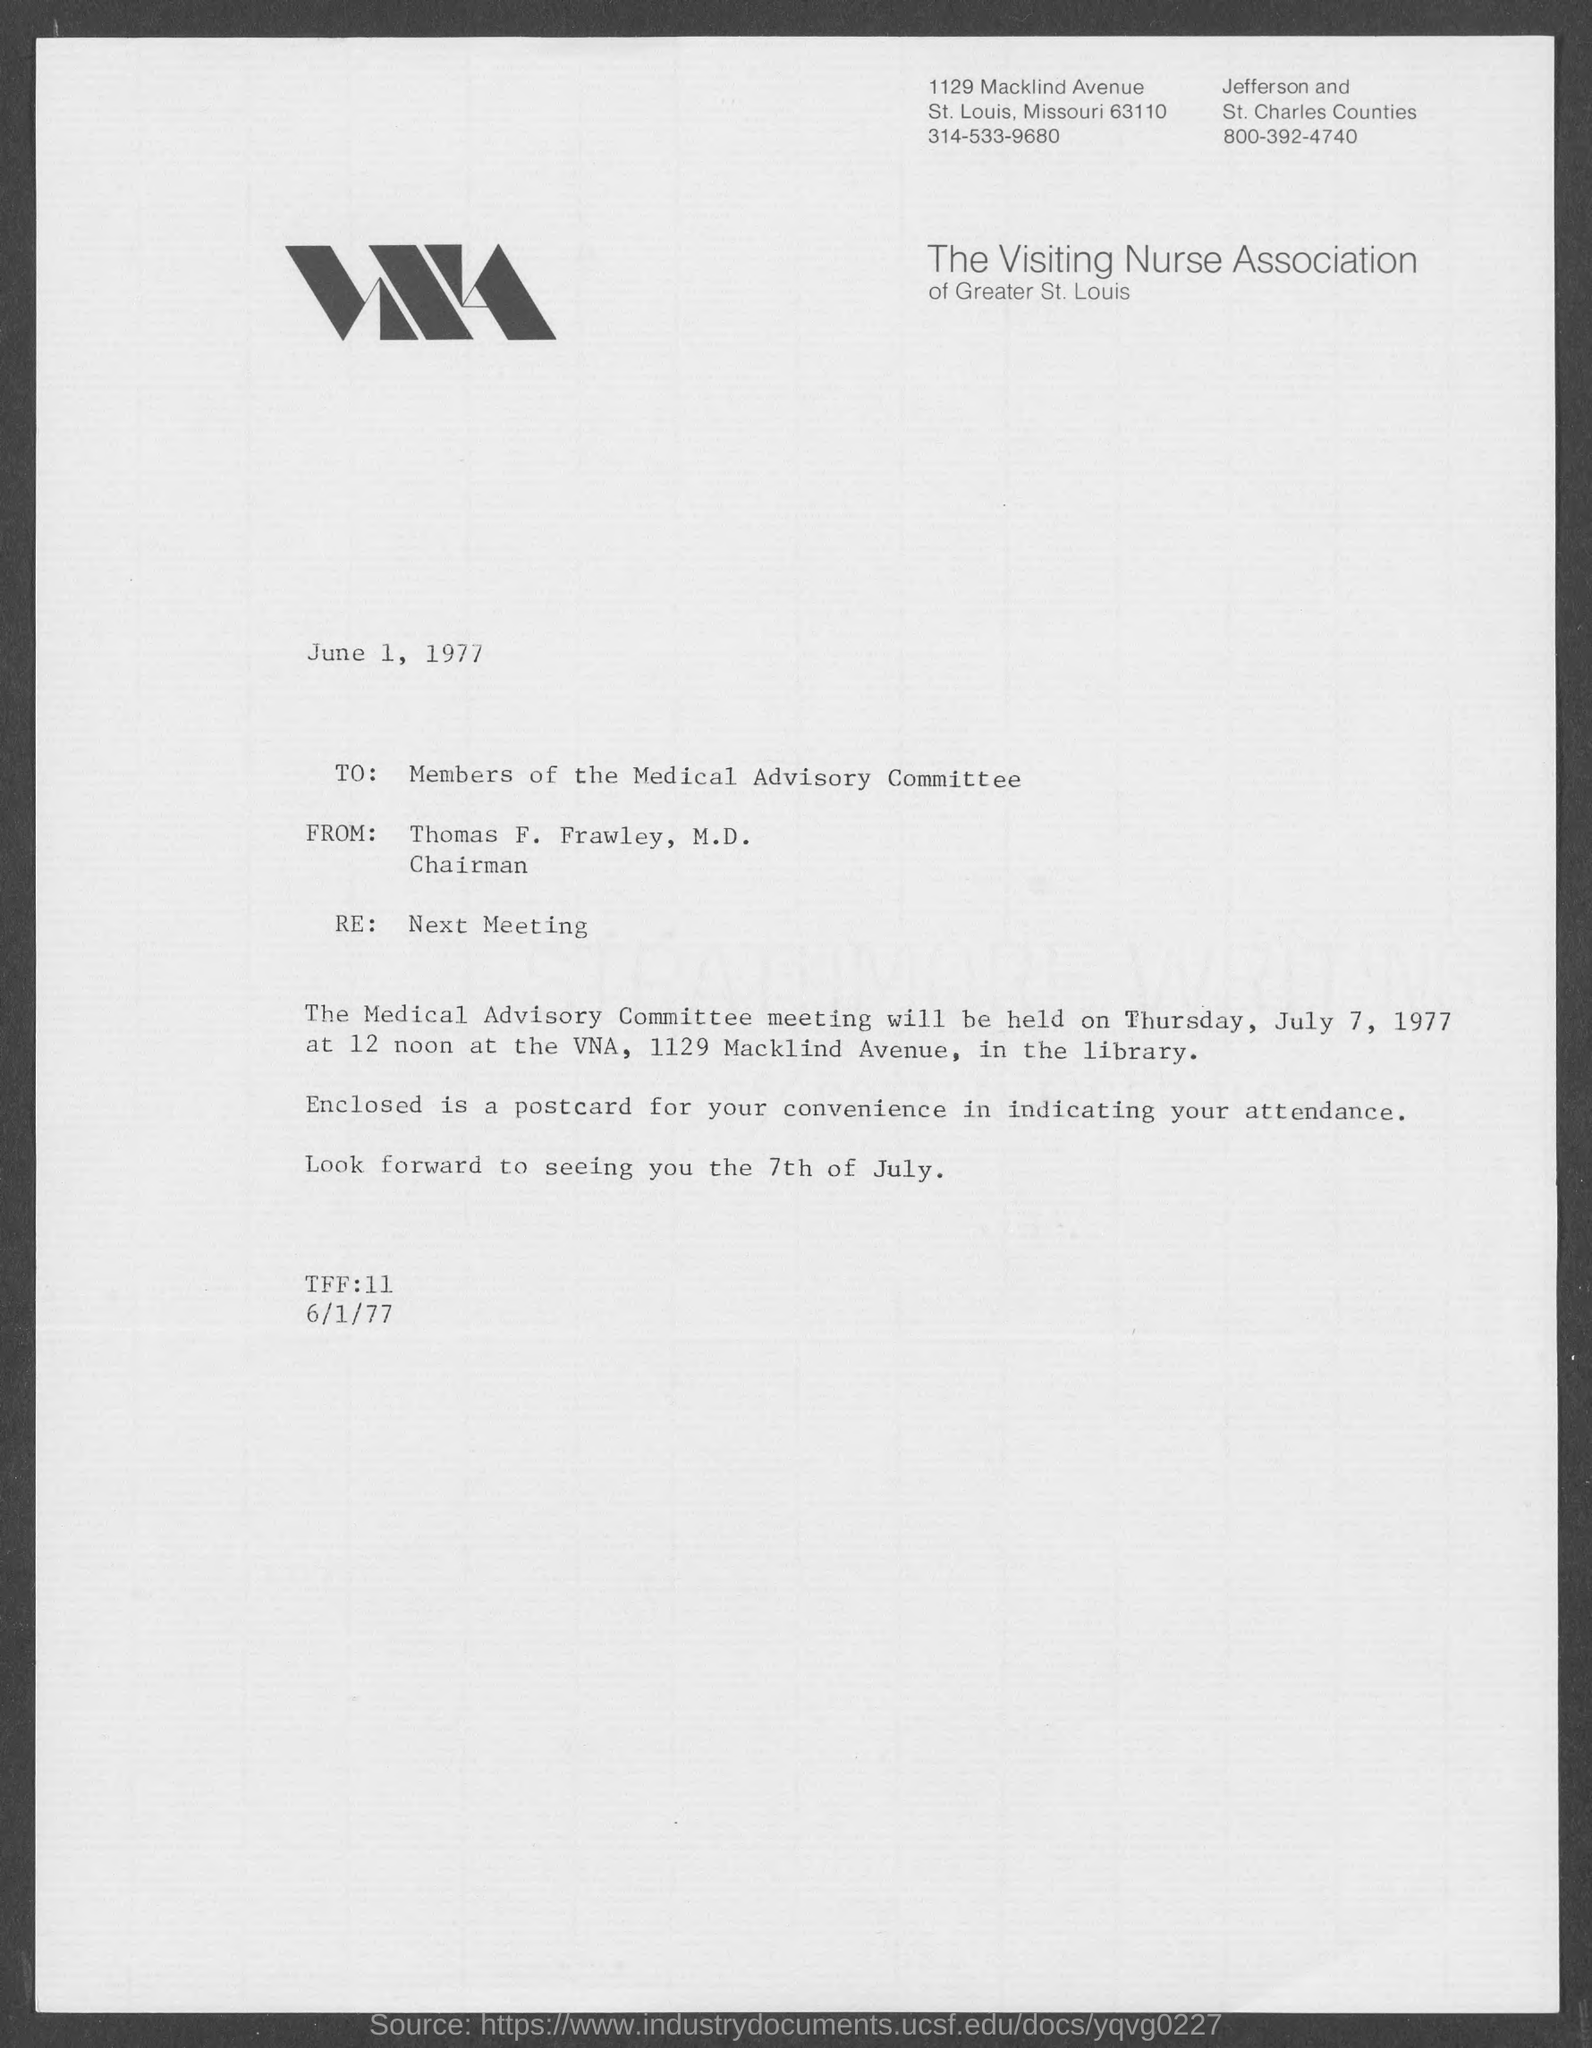Draw attention to some important aspects in this diagram. The memorandum is dated June 1, 1977. Thomas F. Frawley, M.D., is the Chairman. The memorandum is the equivalent of a record of the meeting, and the next meeting is scheduled to take place. 